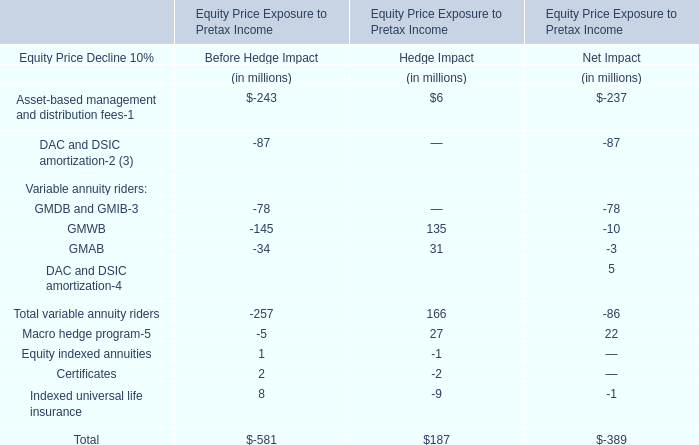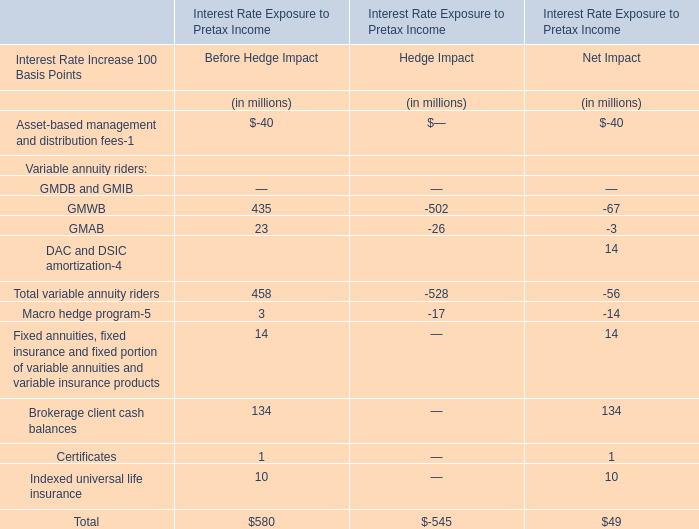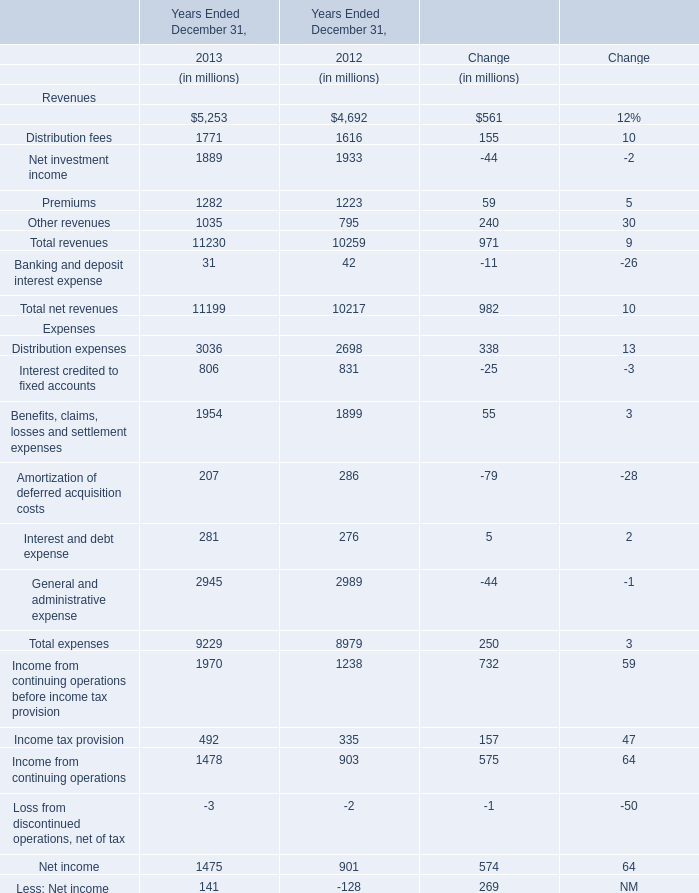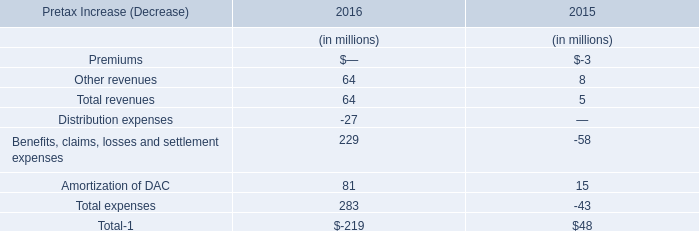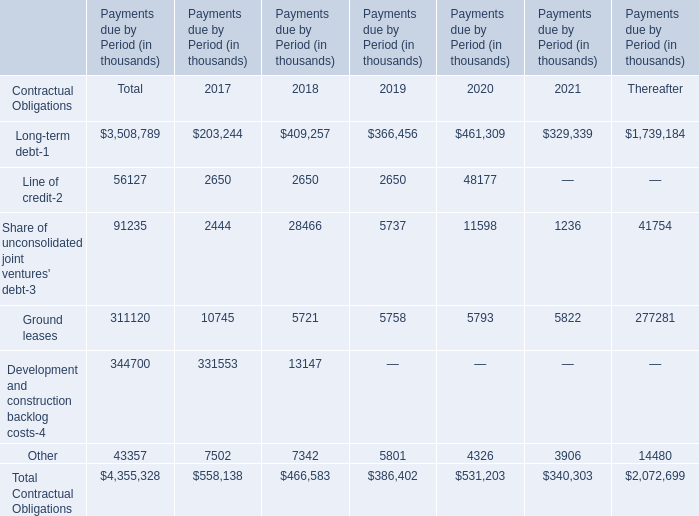what is the percent change in management fees earned from 2015 to 2016? 
Computations: (((6.8 - 4.5) / 4.5) * 100)
Answer: 51.11111. 